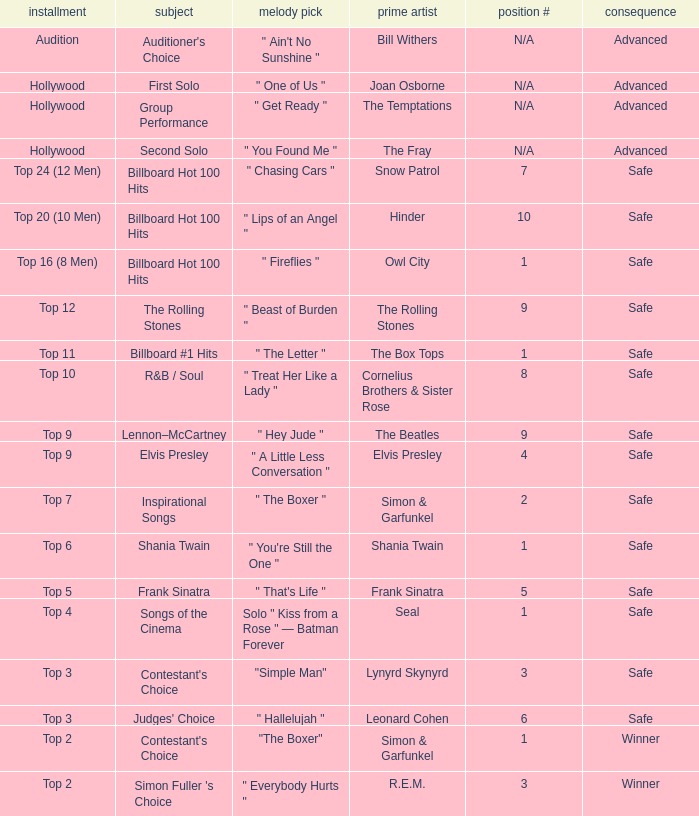Could you parse the entire table as a dict? {'header': ['installment', 'subject', 'melody pick', 'prime artist', 'position #', 'consequence'], 'rows': [['Audition', "Auditioner's Choice", '" Ain\'t No Sunshine "', 'Bill Withers', 'N/A', 'Advanced'], ['Hollywood', 'First Solo', '" One of Us "', 'Joan Osborne', 'N/A', 'Advanced'], ['Hollywood', 'Group Performance', '" Get Ready "', 'The Temptations', 'N/A', 'Advanced'], ['Hollywood', 'Second Solo', '" You Found Me "', 'The Fray', 'N/A', 'Advanced'], ['Top 24 (12 Men)', 'Billboard Hot 100 Hits', '" Chasing Cars "', 'Snow Patrol', '7', 'Safe'], ['Top 20 (10 Men)', 'Billboard Hot 100 Hits', '" Lips of an Angel "', 'Hinder', '10', 'Safe'], ['Top 16 (8 Men)', 'Billboard Hot 100 Hits', '" Fireflies "', 'Owl City', '1', 'Safe'], ['Top 12', 'The Rolling Stones', '" Beast of Burden "', 'The Rolling Stones', '9', 'Safe'], ['Top 11', 'Billboard #1 Hits', '" The Letter "', 'The Box Tops', '1', 'Safe'], ['Top 10', 'R&B / Soul', '" Treat Her Like a Lady "', 'Cornelius Brothers & Sister Rose', '8', 'Safe'], ['Top 9', 'Lennon–McCartney', '" Hey Jude "', 'The Beatles', '9', 'Safe'], ['Top 9', 'Elvis Presley', '" A Little Less Conversation "', 'Elvis Presley', '4', 'Safe'], ['Top 7', 'Inspirational Songs', '" The Boxer "', 'Simon & Garfunkel', '2', 'Safe'], ['Top 6', 'Shania Twain', '" You\'re Still the One "', 'Shania Twain', '1', 'Safe'], ['Top 5', 'Frank Sinatra', '" That\'s Life "', 'Frank Sinatra', '5', 'Safe'], ['Top 4', 'Songs of the Cinema', 'Solo " Kiss from a Rose " — Batman Forever', 'Seal', '1', 'Safe'], ['Top 3', "Contestant's Choice", '"Simple Man"', 'Lynyrd Skynyrd', '3', 'Safe'], ['Top 3', "Judges' Choice", '" Hallelujah "', 'Leonard Cohen', '6', 'Safe'], ['Top 2', "Contestant's Choice", '"The Boxer"', 'Simon & Garfunkel', '1', 'Winner'], ['Top 2', "Simon Fuller 's Choice", '" Everybody Hurts "', 'R.E.M.', '3', 'Winner']]} In which episode is the order number 10? Top 20 (10 Men). 